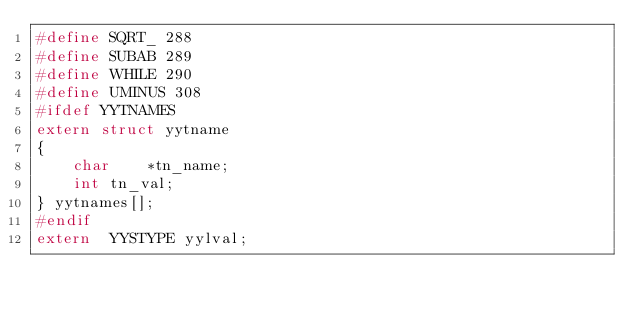Convert code to text. <code><loc_0><loc_0><loc_500><loc_500><_C_>#define SQRT_ 288
#define SUBAB 289
#define WHILE 290
#define UMINUS 308
#ifdef YYTNAMES
extern struct yytname
{
	char	*tn_name;
	int	tn_val;
} yytnames[];
#endif
extern	YYSTYPE	yylval;
</code> 